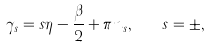<formula> <loc_0><loc_0><loc_500><loc_500>\gamma _ { s } = s \eta - \frac { \beta } { 2 } + \pi n _ { s } , \quad s = \pm ,</formula> 